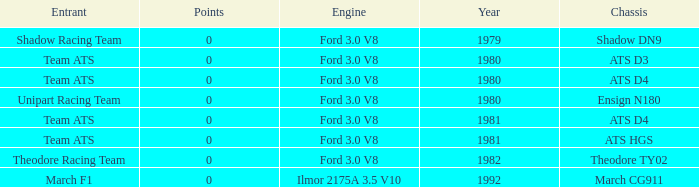What was the lowest year that the engine Ilmor 2175a 3.5 v10 was used? 1992.0. 